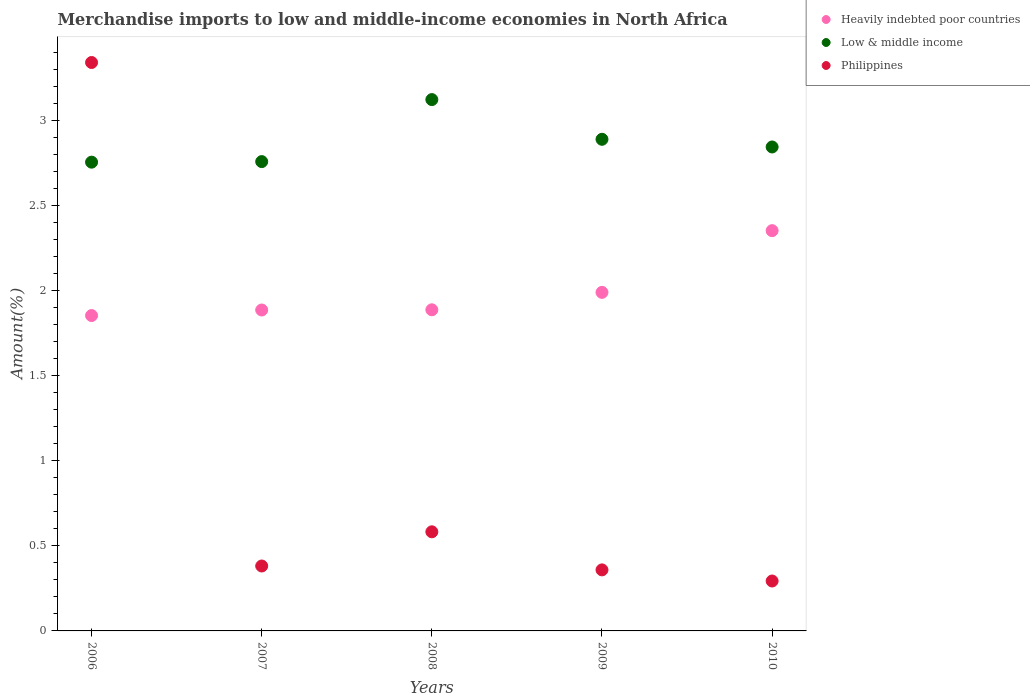Is the number of dotlines equal to the number of legend labels?
Your answer should be compact. Yes. What is the percentage of amount earned from merchandise imports in Heavily indebted poor countries in 2008?
Offer a very short reply. 1.89. Across all years, what is the maximum percentage of amount earned from merchandise imports in Heavily indebted poor countries?
Keep it short and to the point. 2.35. Across all years, what is the minimum percentage of amount earned from merchandise imports in Philippines?
Offer a terse response. 0.29. In which year was the percentage of amount earned from merchandise imports in Low & middle income minimum?
Offer a terse response. 2006. What is the total percentage of amount earned from merchandise imports in Heavily indebted poor countries in the graph?
Give a very brief answer. 9.97. What is the difference between the percentage of amount earned from merchandise imports in Philippines in 2006 and that in 2008?
Give a very brief answer. 2.76. What is the difference between the percentage of amount earned from merchandise imports in Heavily indebted poor countries in 2006 and the percentage of amount earned from merchandise imports in Low & middle income in 2010?
Your response must be concise. -0.99. What is the average percentage of amount earned from merchandise imports in Heavily indebted poor countries per year?
Keep it short and to the point. 1.99. In the year 2010, what is the difference between the percentage of amount earned from merchandise imports in Low & middle income and percentage of amount earned from merchandise imports in Heavily indebted poor countries?
Provide a short and direct response. 0.49. In how many years, is the percentage of amount earned from merchandise imports in Philippines greater than 0.6 %?
Provide a succinct answer. 1. What is the ratio of the percentage of amount earned from merchandise imports in Low & middle income in 2008 to that in 2010?
Provide a succinct answer. 1.1. Is the percentage of amount earned from merchandise imports in Heavily indebted poor countries in 2006 less than that in 2010?
Keep it short and to the point. Yes. What is the difference between the highest and the second highest percentage of amount earned from merchandise imports in Philippines?
Make the answer very short. 2.76. What is the difference between the highest and the lowest percentage of amount earned from merchandise imports in Low & middle income?
Provide a succinct answer. 0.37. In how many years, is the percentage of amount earned from merchandise imports in Heavily indebted poor countries greater than the average percentage of amount earned from merchandise imports in Heavily indebted poor countries taken over all years?
Your answer should be compact. 1. Is the sum of the percentage of amount earned from merchandise imports in Low & middle income in 2009 and 2010 greater than the maximum percentage of amount earned from merchandise imports in Philippines across all years?
Your answer should be compact. Yes. Does the percentage of amount earned from merchandise imports in Low & middle income monotonically increase over the years?
Make the answer very short. No. How many dotlines are there?
Your response must be concise. 3. What is the difference between two consecutive major ticks on the Y-axis?
Ensure brevity in your answer.  0.5. Are the values on the major ticks of Y-axis written in scientific E-notation?
Make the answer very short. No. Does the graph contain any zero values?
Give a very brief answer. No. What is the title of the graph?
Provide a succinct answer. Merchandise imports to low and middle-income economies in North Africa. What is the label or title of the Y-axis?
Provide a short and direct response. Amount(%). What is the Amount(%) in Heavily indebted poor countries in 2006?
Your response must be concise. 1.85. What is the Amount(%) of Low & middle income in 2006?
Offer a very short reply. 2.75. What is the Amount(%) in Philippines in 2006?
Make the answer very short. 3.34. What is the Amount(%) of Heavily indebted poor countries in 2007?
Your response must be concise. 1.89. What is the Amount(%) of Low & middle income in 2007?
Your response must be concise. 2.76. What is the Amount(%) in Philippines in 2007?
Offer a terse response. 0.38. What is the Amount(%) in Heavily indebted poor countries in 2008?
Your answer should be compact. 1.89. What is the Amount(%) of Low & middle income in 2008?
Give a very brief answer. 3.12. What is the Amount(%) of Philippines in 2008?
Make the answer very short. 0.58. What is the Amount(%) of Heavily indebted poor countries in 2009?
Offer a terse response. 1.99. What is the Amount(%) of Low & middle income in 2009?
Ensure brevity in your answer.  2.89. What is the Amount(%) of Philippines in 2009?
Keep it short and to the point. 0.36. What is the Amount(%) in Heavily indebted poor countries in 2010?
Ensure brevity in your answer.  2.35. What is the Amount(%) of Low & middle income in 2010?
Your response must be concise. 2.84. What is the Amount(%) of Philippines in 2010?
Make the answer very short. 0.29. Across all years, what is the maximum Amount(%) of Heavily indebted poor countries?
Your answer should be very brief. 2.35. Across all years, what is the maximum Amount(%) of Low & middle income?
Keep it short and to the point. 3.12. Across all years, what is the maximum Amount(%) in Philippines?
Provide a short and direct response. 3.34. Across all years, what is the minimum Amount(%) in Heavily indebted poor countries?
Offer a very short reply. 1.85. Across all years, what is the minimum Amount(%) in Low & middle income?
Ensure brevity in your answer.  2.75. Across all years, what is the minimum Amount(%) in Philippines?
Your answer should be compact. 0.29. What is the total Amount(%) of Heavily indebted poor countries in the graph?
Keep it short and to the point. 9.97. What is the total Amount(%) of Low & middle income in the graph?
Provide a short and direct response. 14.36. What is the total Amount(%) in Philippines in the graph?
Your response must be concise. 4.96. What is the difference between the Amount(%) of Heavily indebted poor countries in 2006 and that in 2007?
Offer a terse response. -0.03. What is the difference between the Amount(%) in Low & middle income in 2006 and that in 2007?
Ensure brevity in your answer.  -0. What is the difference between the Amount(%) in Philippines in 2006 and that in 2007?
Keep it short and to the point. 2.96. What is the difference between the Amount(%) of Heavily indebted poor countries in 2006 and that in 2008?
Make the answer very short. -0.03. What is the difference between the Amount(%) in Low & middle income in 2006 and that in 2008?
Give a very brief answer. -0.37. What is the difference between the Amount(%) of Philippines in 2006 and that in 2008?
Provide a succinct answer. 2.76. What is the difference between the Amount(%) in Heavily indebted poor countries in 2006 and that in 2009?
Make the answer very short. -0.14. What is the difference between the Amount(%) of Low & middle income in 2006 and that in 2009?
Provide a short and direct response. -0.13. What is the difference between the Amount(%) in Philippines in 2006 and that in 2009?
Your answer should be very brief. 2.98. What is the difference between the Amount(%) in Heavily indebted poor countries in 2006 and that in 2010?
Ensure brevity in your answer.  -0.5. What is the difference between the Amount(%) of Low & middle income in 2006 and that in 2010?
Keep it short and to the point. -0.09. What is the difference between the Amount(%) of Philippines in 2006 and that in 2010?
Make the answer very short. 3.05. What is the difference between the Amount(%) in Heavily indebted poor countries in 2007 and that in 2008?
Ensure brevity in your answer.  -0. What is the difference between the Amount(%) of Low & middle income in 2007 and that in 2008?
Your response must be concise. -0.36. What is the difference between the Amount(%) in Philippines in 2007 and that in 2008?
Ensure brevity in your answer.  -0.2. What is the difference between the Amount(%) in Heavily indebted poor countries in 2007 and that in 2009?
Make the answer very short. -0.1. What is the difference between the Amount(%) of Low & middle income in 2007 and that in 2009?
Your answer should be very brief. -0.13. What is the difference between the Amount(%) in Philippines in 2007 and that in 2009?
Offer a very short reply. 0.02. What is the difference between the Amount(%) in Heavily indebted poor countries in 2007 and that in 2010?
Your answer should be compact. -0.47. What is the difference between the Amount(%) in Low & middle income in 2007 and that in 2010?
Your answer should be compact. -0.09. What is the difference between the Amount(%) in Philippines in 2007 and that in 2010?
Make the answer very short. 0.09. What is the difference between the Amount(%) in Heavily indebted poor countries in 2008 and that in 2009?
Offer a terse response. -0.1. What is the difference between the Amount(%) in Low & middle income in 2008 and that in 2009?
Your answer should be very brief. 0.23. What is the difference between the Amount(%) in Philippines in 2008 and that in 2009?
Your answer should be very brief. 0.22. What is the difference between the Amount(%) in Heavily indebted poor countries in 2008 and that in 2010?
Give a very brief answer. -0.47. What is the difference between the Amount(%) in Low & middle income in 2008 and that in 2010?
Your answer should be compact. 0.28. What is the difference between the Amount(%) of Philippines in 2008 and that in 2010?
Keep it short and to the point. 0.29. What is the difference between the Amount(%) in Heavily indebted poor countries in 2009 and that in 2010?
Your response must be concise. -0.36. What is the difference between the Amount(%) of Low & middle income in 2009 and that in 2010?
Provide a short and direct response. 0.05. What is the difference between the Amount(%) in Philippines in 2009 and that in 2010?
Make the answer very short. 0.07. What is the difference between the Amount(%) in Heavily indebted poor countries in 2006 and the Amount(%) in Low & middle income in 2007?
Keep it short and to the point. -0.9. What is the difference between the Amount(%) in Heavily indebted poor countries in 2006 and the Amount(%) in Philippines in 2007?
Your response must be concise. 1.47. What is the difference between the Amount(%) in Low & middle income in 2006 and the Amount(%) in Philippines in 2007?
Give a very brief answer. 2.37. What is the difference between the Amount(%) of Heavily indebted poor countries in 2006 and the Amount(%) of Low & middle income in 2008?
Keep it short and to the point. -1.27. What is the difference between the Amount(%) of Heavily indebted poor countries in 2006 and the Amount(%) of Philippines in 2008?
Provide a short and direct response. 1.27. What is the difference between the Amount(%) in Low & middle income in 2006 and the Amount(%) in Philippines in 2008?
Offer a terse response. 2.17. What is the difference between the Amount(%) in Heavily indebted poor countries in 2006 and the Amount(%) in Low & middle income in 2009?
Give a very brief answer. -1.04. What is the difference between the Amount(%) of Heavily indebted poor countries in 2006 and the Amount(%) of Philippines in 2009?
Provide a succinct answer. 1.49. What is the difference between the Amount(%) of Low & middle income in 2006 and the Amount(%) of Philippines in 2009?
Your answer should be very brief. 2.4. What is the difference between the Amount(%) of Heavily indebted poor countries in 2006 and the Amount(%) of Low & middle income in 2010?
Make the answer very short. -0.99. What is the difference between the Amount(%) of Heavily indebted poor countries in 2006 and the Amount(%) of Philippines in 2010?
Your answer should be compact. 1.56. What is the difference between the Amount(%) in Low & middle income in 2006 and the Amount(%) in Philippines in 2010?
Keep it short and to the point. 2.46. What is the difference between the Amount(%) of Heavily indebted poor countries in 2007 and the Amount(%) of Low & middle income in 2008?
Offer a terse response. -1.24. What is the difference between the Amount(%) in Heavily indebted poor countries in 2007 and the Amount(%) in Philippines in 2008?
Keep it short and to the point. 1.3. What is the difference between the Amount(%) in Low & middle income in 2007 and the Amount(%) in Philippines in 2008?
Keep it short and to the point. 2.17. What is the difference between the Amount(%) of Heavily indebted poor countries in 2007 and the Amount(%) of Low & middle income in 2009?
Your answer should be compact. -1. What is the difference between the Amount(%) of Heavily indebted poor countries in 2007 and the Amount(%) of Philippines in 2009?
Make the answer very short. 1.53. What is the difference between the Amount(%) of Low & middle income in 2007 and the Amount(%) of Philippines in 2009?
Give a very brief answer. 2.4. What is the difference between the Amount(%) in Heavily indebted poor countries in 2007 and the Amount(%) in Low & middle income in 2010?
Your response must be concise. -0.96. What is the difference between the Amount(%) of Heavily indebted poor countries in 2007 and the Amount(%) of Philippines in 2010?
Your answer should be very brief. 1.59. What is the difference between the Amount(%) of Low & middle income in 2007 and the Amount(%) of Philippines in 2010?
Ensure brevity in your answer.  2.46. What is the difference between the Amount(%) in Heavily indebted poor countries in 2008 and the Amount(%) in Low & middle income in 2009?
Ensure brevity in your answer.  -1. What is the difference between the Amount(%) of Heavily indebted poor countries in 2008 and the Amount(%) of Philippines in 2009?
Offer a very short reply. 1.53. What is the difference between the Amount(%) in Low & middle income in 2008 and the Amount(%) in Philippines in 2009?
Ensure brevity in your answer.  2.76. What is the difference between the Amount(%) of Heavily indebted poor countries in 2008 and the Amount(%) of Low & middle income in 2010?
Offer a very short reply. -0.96. What is the difference between the Amount(%) of Heavily indebted poor countries in 2008 and the Amount(%) of Philippines in 2010?
Offer a very short reply. 1.59. What is the difference between the Amount(%) in Low & middle income in 2008 and the Amount(%) in Philippines in 2010?
Keep it short and to the point. 2.83. What is the difference between the Amount(%) in Heavily indebted poor countries in 2009 and the Amount(%) in Low & middle income in 2010?
Keep it short and to the point. -0.85. What is the difference between the Amount(%) in Heavily indebted poor countries in 2009 and the Amount(%) in Philippines in 2010?
Make the answer very short. 1.7. What is the difference between the Amount(%) in Low & middle income in 2009 and the Amount(%) in Philippines in 2010?
Keep it short and to the point. 2.6. What is the average Amount(%) of Heavily indebted poor countries per year?
Give a very brief answer. 1.99. What is the average Amount(%) in Low & middle income per year?
Your answer should be compact. 2.87. What is the average Amount(%) in Philippines per year?
Ensure brevity in your answer.  0.99. In the year 2006, what is the difference between the Amount(%) of Heavily indebted poor countries and Amount(%) of Low & middle income?
Your answer should be compact. -0.9. In the year 2006, what is the difference between the Amount(%) in Heavily indebted poor countries and Amount(%) in Philippines?
Offer a terse response. -1.49. In the year 2006, what is the difference between the Amount(%) in Low & middle income and Amount(%) in Philippines?
Provide a short and direct response. -0.59. In the year 2007, what is the difference between the Amount(%) of Heavily indebted poor countries and Amount(%) of Low & middle income?
Provide a short and direct response. -0.87. In the year 2007, what is the difference between the Amount(%) of Heavily indebted poor countries and Amount(%) of Philippines?
Provide a succinct answer. 1.5. In the year 2007, what is the difference between the Amount(%) of Low & middle income and Amount(%) of Philippines?
Your answer should be very brief. 2.38. In the year 2008, what is the difference between the Amount(%) in Heavily indebted poor countries and Amount(%) in Low & middle income?
Your answer should be compact. -1.24. In the year 2008, what is the difference between the Amount(%) in Heavily indebted poor countries and Amount(%) in Philippines?
Your response must be concise. 1.3. In the year 2008, what is the difference between the Amount(%) of Low & middle income and Amount(%) of Philippines?
Your answer should be compact. 2.54. In the year 2009, what is the difference between the Amount(%) in Heavily indebted poor countries and Amount(%) in Low & middle income?
Offer a very short reply. -0.9. In the year 2009, what is the difference between the Amount(%) of Heavily indebted poor countries and Amount(%) of Philippines?
Make the answer very short. 1.63. In the year 2009, what is the difference between the Amount(%) of Low & middle income and Amount(%) of Philippines?
Make the answer very short. 2.53. In the year 2010, what is the difference between the Amount(%) of Heavily indebted poor countries and Amount(%) of Low & middle income?
Ensure brevity in your answer.  -0.49. In the year 2010, what is the difference between the Amount(%) of Heavily indebted poor countries and Amount(%) of Philippines?
Give a very brief answer. 2.06. In the year 2010, what is the difference between the Amount(%) of Low & middle income and Amount(%) of Philippines?
Offer a terse response. 2.55. What is the ratio of the Amount(%) in Heavily indebted poor countries in 2006 to that in 2007?
Offer a very short reply. 0.98. What is the ratio of the Amount(%) in Philippines in 2006 to that in 2007?
Your response must be concise. 8.76. What is the ratio of the Amount(%) in Heavily indebted poor countries in 2006 to that in 2008?
Your response must be concise. 0.98. What is the ratio of the Amount(%) of Low & middle income in 2006 to that in 2008?
Give a very brief answer. 0.88. What is the ratio of the Amount(%) in Philippines in 2006 to that in 2008?
Offer a very short reply. 5.74. What is the ratio of the Amount(%) in Heavily indebted poor countries in 2006 to that in 2009?
Offer a terse response. 0.93. What is the ratio of the Amount(%) of Low & middle income in 2006 to that in 2009?
Your response must be concise. 0.95. What is the ratio of the Amount(%) in Philippines in 2006 to that in 2009?
Offer a very short reply. 9.31. What is the ratio of the Amount(%) of Heavily indebted poor countries in 2006 to that in 2010?
Give a very brief answer. 0.79. What is the ratio of the Amount(%) in Low & middle income in 2006 to that in 2010?
Ensure brevity in your answer.  0.97. What is the ratio of the Amount(%) of Philippines in 2006 to that in 2010?
Give a very brief answer. 11.39. What is the ratio of the Amount(%) in Low & middle income in 2007 to that in 2008?
Provide a succinct answer. 0.88. What is the ratio of the Amount(%) in Philippines in 2007 to that in 2008?
Offer a very short reply. 0.66. What is the ratio of the Amount(%) of Heavily indebted poor countries in 2007 to that in 2009?
Your answer should be compact. 0.95. What is the ratio of the Amount(%) in Low & middle income in 2007 to that in 2009?
Ensure brevity in your answer.  0.95. What is the ratio of the Amount(%) in Philippines in 2007 to that in 2009?
Offer a very short reply. 1.06. What is the ratio of the Amount(%) of Heavily indebted poor countries in 2007 to that in 2010?
Provide a short and direct response. 0.8. What is the ratio of the Amount(%) of Low & middle income in 2007 to that in 2010?
Make the answer very short. 0.97. What is the ratio of the Amount(%) of Philippines in 2007 to that in 2010?
Offer a terse response. 1.3. What is the ratio of the Amount(%) of Heavily indebted poor countries in 2008 to that in 2009?
Your answer should be compact. 0.95. What is the ratio of the Amount(%) in Low & middle income in 2008 to that in 2009?
Provide a short and direct response. 1.08. What is the ratio of the Amount(%) of Philippines in 2008 to that in 2009?
Your answer should be very brief. 1.62. What is the ratio of the Amount(%) in Heavily indebted poor countries in 2008 to that in 2010?
Ensure brevity in your answer.  0.8. What is the ratio of the Amount(%) in Low & middle income in 2008 to that in 2010?
Provide a succinct answer. 1.1. What is the ratio of the Amount(%) in Philippines in 2008 to that in 2010?
Keep it short and to the point. 1.99. What is the ratio of the Amount(%) in Heavily indebted poor countries in 2009 to that in 2010?
Your answer should be very brief. 0.85. What is the ratio of the Amount(%) in Low & middle income in 2009 to that in 2010?
Offer a very short reply. 1.02. What is the ratio of the Amount(%) of Philippines in 2009 to that in 2010?
Your response must be concise. 1.22. What is the difference between the highest and the second highest Amount(%) of Heavily indebted poor countries?
Your answer should be very brief. 0.36. What is the difference between the highest and the second highest Amount(%) of Low & middle income?
Give a very brief answer. 0.23. What is the difference between the highest and the second highest Amount(%) of Philippines?
Offer a very short reply. 2.76. What is the difference between the highest and the lowest Amount(%) of Heavily indebted poor countries?
Ensure brevity in your answer.  0.5. What is the difference between the highest and the lowest Amount(%) in Low & middle income?
Provide a succinct answer. 0.37. What is the difference between the highest and the lowest Amount(%) of Philippines?
Offer a terse response. 3.05. 